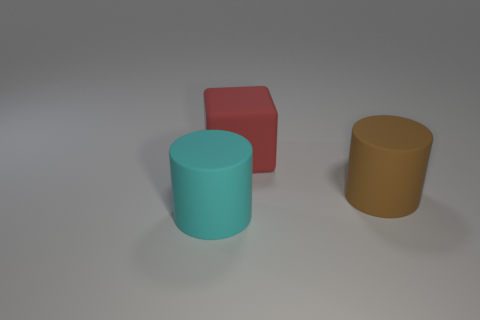Subtract all yellow cylinders. Subtract all purple blocks. How many cylinders are left? 2 Subtract all yellow cylinders. How many green blocks are left? 0 Add 2 large yellows. How many reds exist? 0 Subtract all large cylinders. Subtract all large cyan objects. How many objects are left? 0 Add 1 big cyan matte things. How many big cyan matte things are left? 2 Add 2 red matte blocks. How many red matte blocks exist? 3 Add 2 large gray cylinders. How many objects exist? 5 Subtract all cyan cylinders. How many cylinders are left? 1 Subtract 1 red blocks. How many objects are left? 2 Subtract all cylinders. How many objects are left? 1 